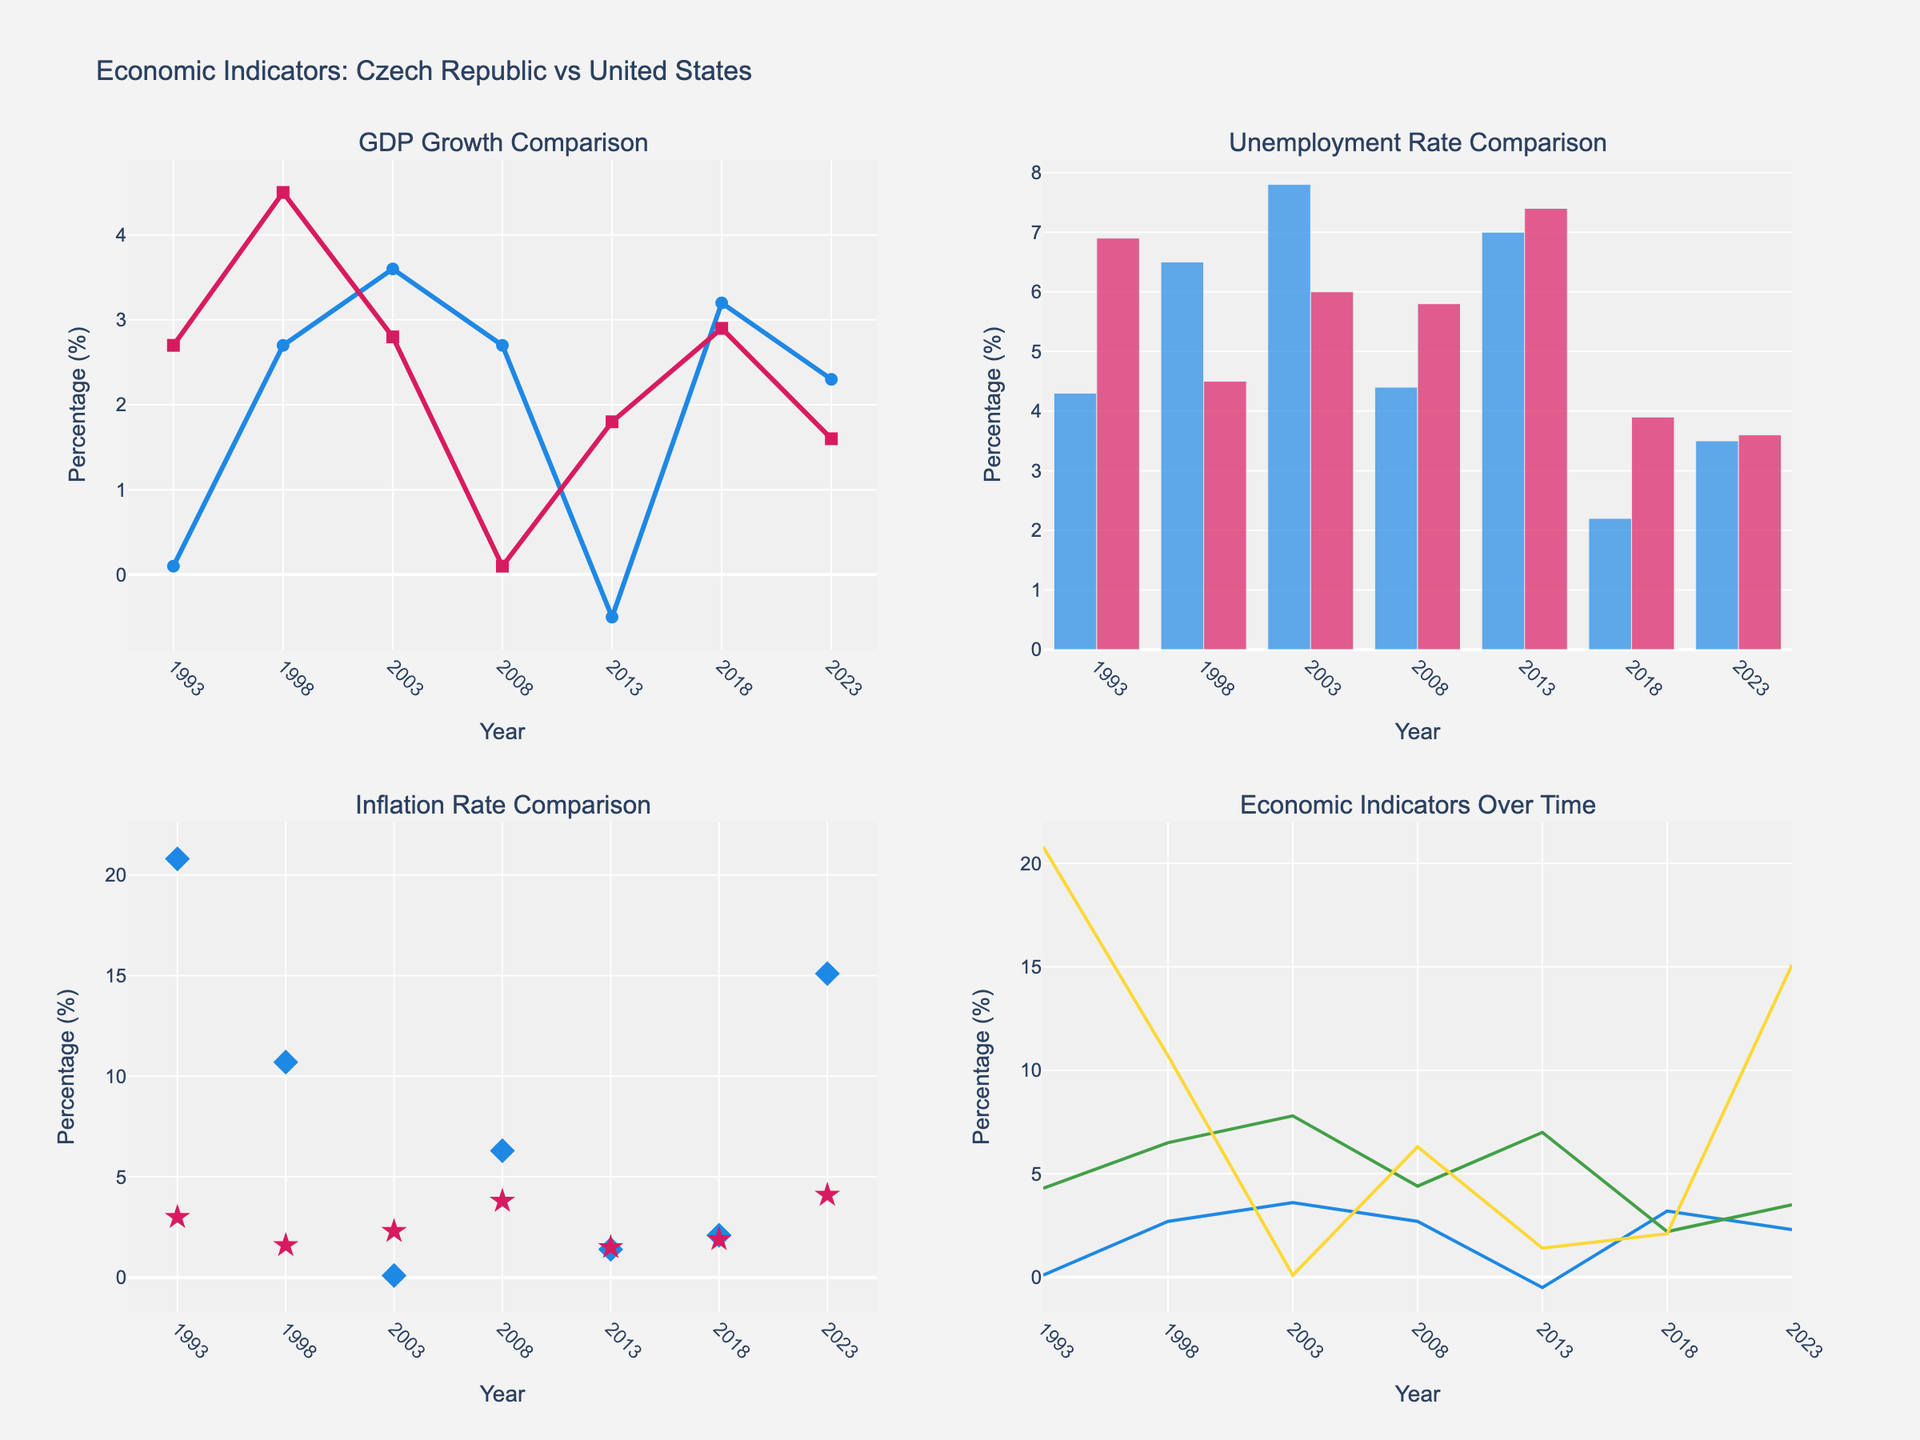What is the title of the figure? The title of the figure is displayed at the top of the plot. It reads "Economic Indicators: Czech Republic vs United States".
Answer: Economic Indicators: Czech Republic vs United States Between 1993 and 2023, which country had the year with the highest inflation rate? From the scatter plot comparing inflation rates, we see that the Czech Republic has the highest inflation rate in 1993 at 20.8%.
Answer: Czech Republic What was the GDP growth of the United States in 2018? The line chart for GDP growth comparison shows two lines. The red line representing the United States indicates a GDP growth rate of 2.9% in 2018.
Answer: 2.9% In which year was the unemployment rate in the Czech Republic the highest? The bar chart for unemployment rate comparison shows that the highest bar for the Czech Republic appears in 2003, indicating a peak unemployment rate of 7.8%.
Answer: 2003 Compare the inflation rate of the Czech Republic and the United States in 2008. Which country had a higher rate? The scatter plot showing inflation rates indicates that in 2008, the Czech Republic had an inflation rate of 6.3%, while the United States had a rate of 3.8%. Therefore, the Czech Republic had a higher inflation rate in that year.
Answer: Czech Republic What is the trend in the Czech Republic's GDP growth from 1993 to 2023? Observing the line chart for Czech GDP growth over time, it starts low in 1993, increases modestly by 1998, reaches a peak in 2003, fluctuates but generally decreases to a negative value in 2013, and then increases again by 2023.
Answer: Fluctuating with general increase after decline What was the difference in GDP growth rates between the Czech Republic and the United States in 2013? From the GDP growth comparison line chart, the Czech Republic had a GDP growth of -0.5% in 2013, and the United States had 1.8%. The difference is calculated by subtracting -0.5 from 1.8, yielding 2.3%.
Answer: 2.3% Which country had a lower unemployment rate in 2023? In the bar chart, the unemployment rate for both countries in 2023 can be compared. The Czech Republic has an unemployment rate of 3.5%, while the United States has a rate of 3.6%. Therefore, the Czech Republic had a slightly lower unemployment rate in 2023.
Answer: Czech Republic How did the inflation rate in the United States change from 1993 to 2023? Observing the scatter plot for the United States' inflation rates, it starts at 3.0% in 1993, decreases overall with some fluctuations, reaching a peak again at 4.1% in 2023.
Answer: Increased overall 